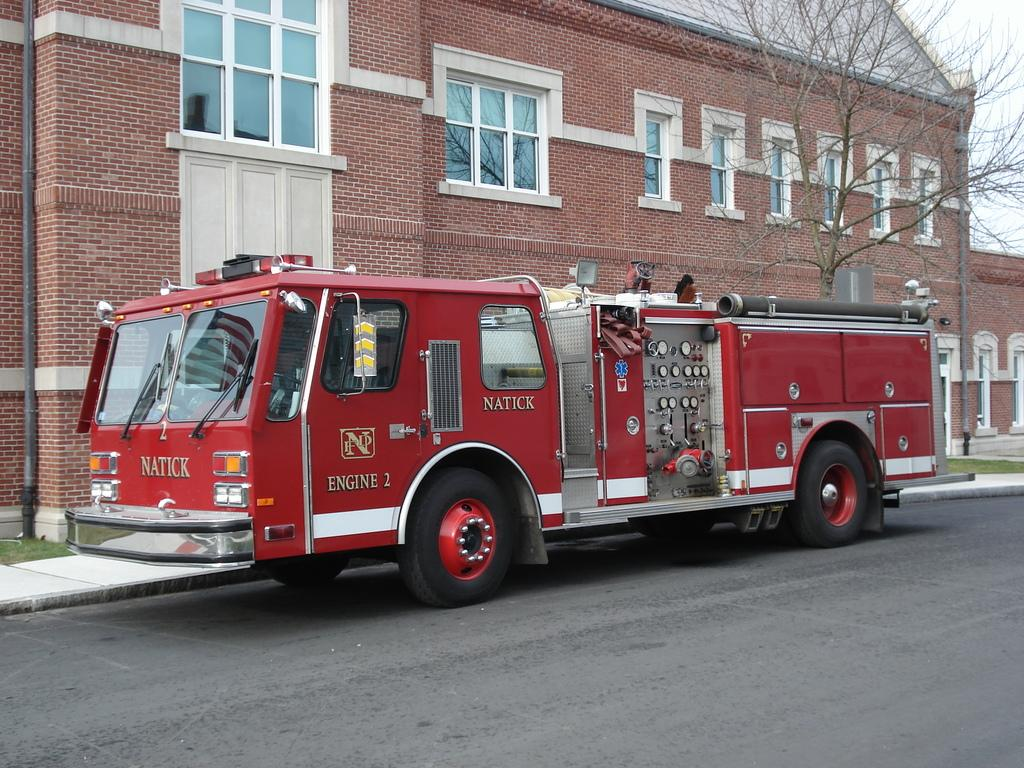What is on the road in the image? There is a vehicle on the road in the image. What can be seen in the distance behind the vehicle? There are buildings and a tree in the background of the image. What part of the natural environment is visible in the image? The sky is visible in the background of the image. Where is the pear located in the image? There is no pear present in the image. Can you describe the frog's behavior in the image? There is no frog present in the image, so its behavior cannot be described. 